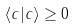<formula> <loc_0><loc_0><loc_500><loc_500>\langle c | c \rangle \geq 0</formula> 